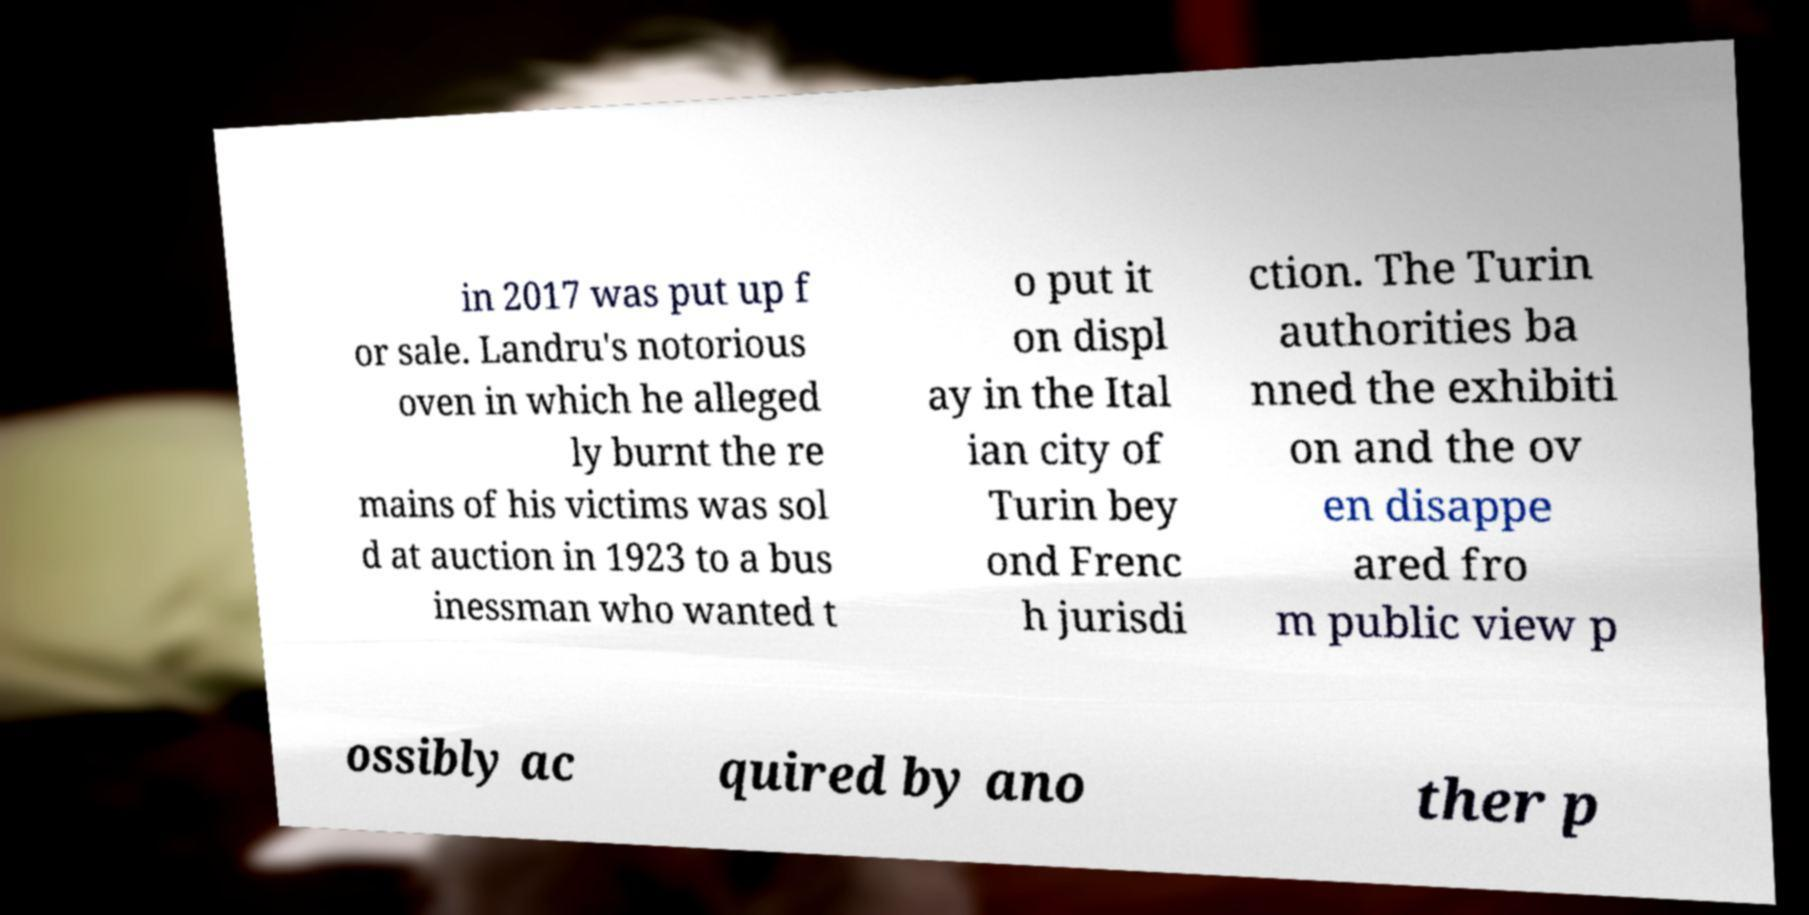Can you accurately transcribe the text from the provided image for me? in 2017 was put up f or sale. Landru's notorious oven in which he alleged ly burnt the re mains of his victims was sol d at auction in 1923 to a bus inessman who wanted t o put it on displ ay in the Ital ian city of Turin bey ond Frenc h jurisdi ction. The Turin authorities ba nned the exhibiti on and the ov en disappe ared fro m public view p ossibly ac quired by ano ther p 